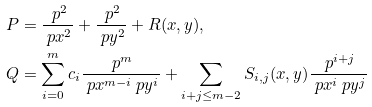<formula> <loc_0><loc_0><loc_500><loc_500>P & = \frac { \ p ^ { 2 } } { \ p x ^ { 2 } } + \frac { \ p ^ { 2 } } { \ p y ^ { 2 } } + R ( x , y ) , \\ Q & = \sum _ { i = 0 } ^ { m } c _ { i } \frac { \ p ^ { m } } { \ p x ^ { m - i } \ p y ^ { i } } + \sum _ { i + j \leq m - 2 } S _ { i , j } ( x , y ) \frac { \ p ^ { i + j } } { \ p x ^ { i } \ p y ^ { j } }</formula> 